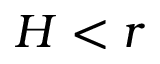Convert formula to latex. <formula><loc_0><loc_0><loc_500><loc_500>H < r</formula> 